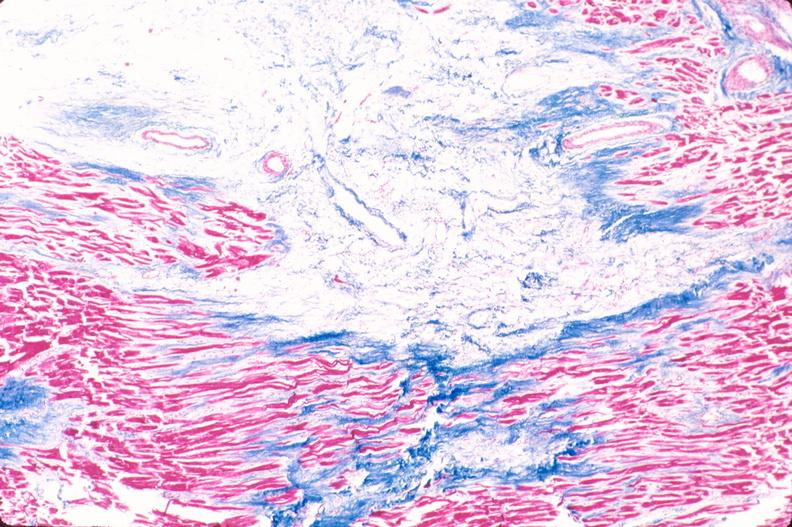s carcinomatosis endometrium primary present?
Answer the question using a single word or phrase. No 